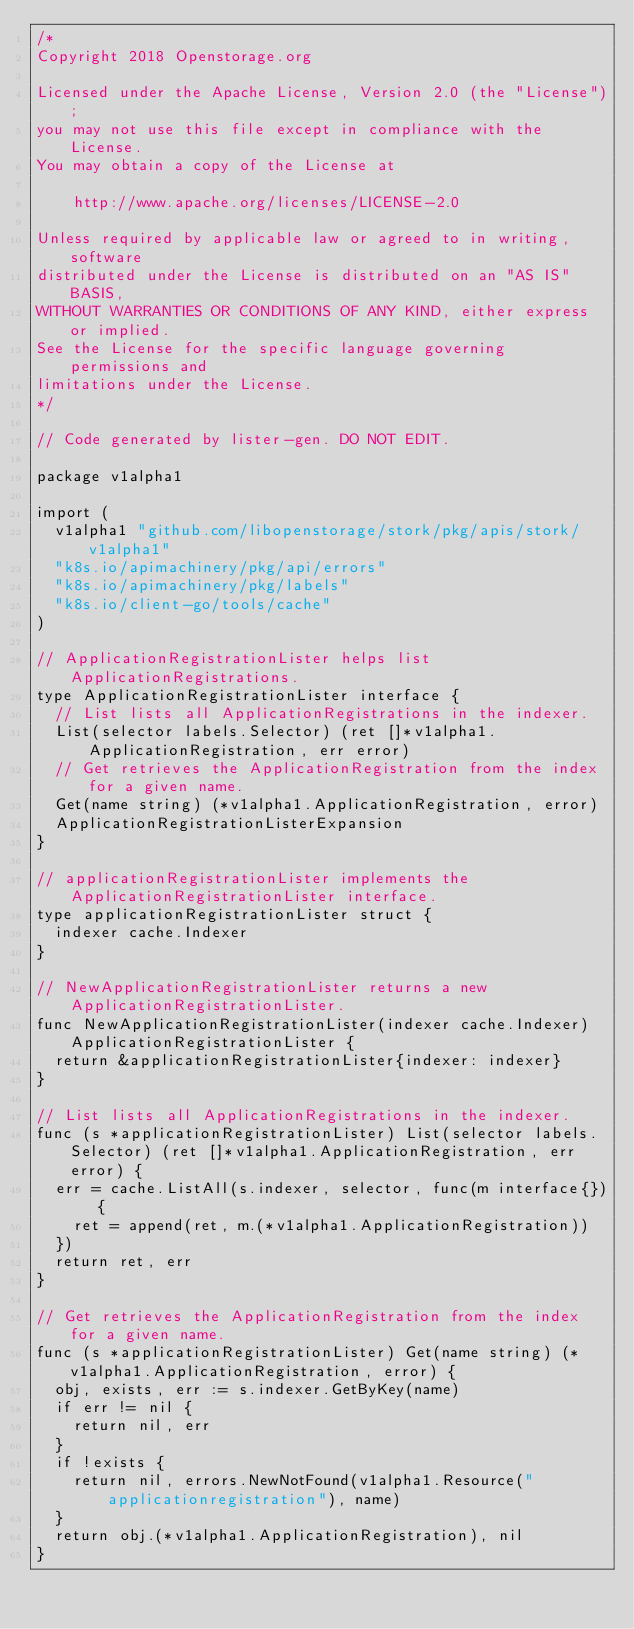Convert code to text. <code><loc_0><loc_0><loc_500><loc_500><_Go_>/*
Copyright 2018 Openstorage.org

Licensed under the Apache License, Version 2.0 (the "License");
you may not use this file except in compliance with the License.
You may obtain a copy of the License at

    http://www.apache.org/licenses/LICENSE-2.0

Unless required by applicable law or agreed to in writing, software
distributed under the License is distributed on an "AS IS" BASIS,
WITHOUT WARRANTIES OR CONDITIONS OF ANY KIND, either express or implied.
See the License for the specific language governing permissions and
limitations under the License.
*/

// Code generated by lister-gen. DO NOT EDIT.

package v1alpha1

import (
	v1alpha1 "github.com/libopenstorage/stork/pkg/apis/stork/v1alpha1"
	"k8s.io/apimachinery/pkg/api/errors"
	"k8s.io/apimachinery/pkg/labels"
	"k8s.io/client-go/tools/cache"
)

// ApplicationRegistrationLister helps list ApplicationRegistrations.
type ApplicationRegistrationLister interface {
	// List lists all ApplicationRegistrations in the indexer.
	List(selector labels.Selector) (ret []*v1alpha1.ApplicationRegistration, err error)
	// Get retrieves the ApplicationRegistration from the index for a given name.
	Get(name string) (*v1alpha1.ApplicationRegistration, error)
	ApplicationRegistrationListerExpansion
}

// applicationRegistrationLister implements the ApplicationRegistrationLister interface.
type applicationRegistrationLister struct {
	indexer cache.Indexer
}

// NewApplicationRegistrationLister returns a new ApplicationRegistrationLister.
func NewApplicationRegistrationLister(indexer cache.Indexer) ApplicationRegistrationLister {
	return &applicationRegistrationLister{indexer: indexer}
}

// List lists all ApplicationRegistrations in the indexer.
func (s *applicationRegistrationLister) List(selector labels.Selector) (ret []*v1alpha1.ApplicationRegistration, err error) {
	err = cache.ListAll(s.indexer, selector, func(m interface{}) {
		ret = append(ret, m.(*v1alpha1.ApplicationRegistration))
	})
	return ret, err
}

// Get retrieves the ApplicationRegistration from the index for a given name.
func (s *applicationRegistrationLister) Get(name string) (*v1alpha1.ApplicationRegistration, error) {
	obj, exists, err := s.indexer.GetByKey(name)
	if err != nil {
		return nil, err
	}
	if !exists {
		return nil, errors.NewNotFound(v1alpha1.Resource("applicationregistration"), name)
	}
	return obj.(*v1alpha1.ApplicationRegistration), nil
}
</code> 